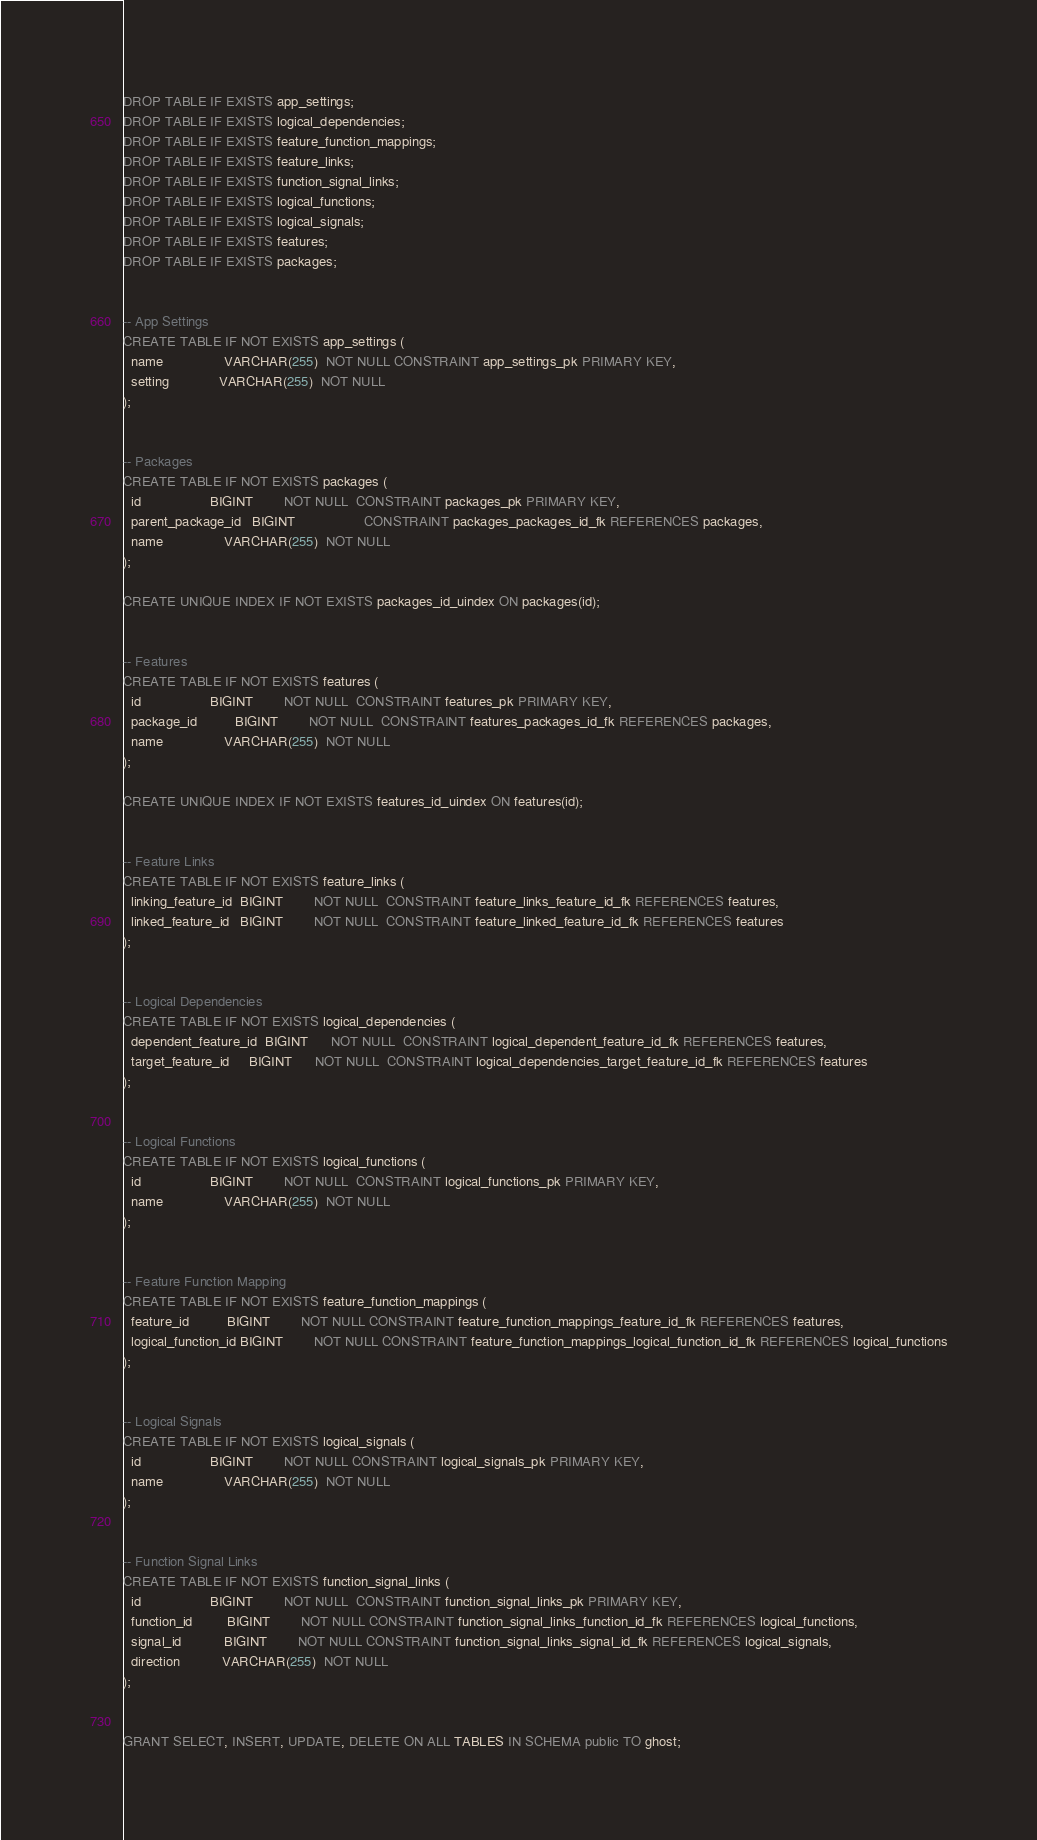<code> <loc_0><loc_0><loc_500><loc_500><_SQL_>DROP TABLE IF EXISTS app_settings;
DROP TABLE IF EXISTS logical_dependencies;
DROP TABLE IF EXISTS feature_function_mappings;
DROP TABLE IF EXISTS feature_links;
DROP TABLE IF EXISTS function_signal_links;
DROP TABLE IF EXISTS logical_functions;
DROP TABLE IF EXISTS logical_signals;
DROP TABLE IF EXISTS features;
DROP TABLE IF EXISTS packages;


-- App Settings
CREATE TABLE IF NOT EXISTS app_settings (
  name                VARCHAR(255)  NOT NULL CONSTRAINT app_settings_pk PRIMARY KEY,
  setting             VARCHAR(255)  NOT NULL
);


-- Packages
CREATE TABLE IF NOT EXISTS packages (
  id                  BIGINT        NOT NULL  CONSTRAINT packages_pk PRIMARY KEY,
  parent_package_id   BIGINT                  CONSTRAINT packages_packages_id_fk REFERENCES packages,
  name                VARCHAR(255)  NOT NULL
);

CREATE UNIQUE INDEX IF NOT EXISTS packages_id_uindex ON packages(id);


-- Features
CREATE TABLE IF NOT EXISTS features (
  id                  BIGINT        NOT NULL  CONSTRAINT features_pk PRIMARY KEY,
  package_id          BIGINT        NOT NULL  CONSTRAINT features_packages_id_fk REFERENCES packages,
  name                VARCHAR(255)  NOT NULL
);

CREATE UNIQUE INDEX IF NOT EXISTS features_id_uindex ON features(id);


-- Feature Links
CREATE TABLE IF NOT EXISTS feature_links (
  linking_feature_id  BIGINT        NOT NULL  CONSTRAINT feature_links_feature_id_fk REFERENCES features,
  linked_feature_id   BIGINT        NOT NULL  CONSTRAINT feature_linked_feature_id_fk REFERENCES features
);


-- Logical Dependencies
CREATE TABLE IF NOT EXISTS logical_dependencies (
  dependent_feature_id  BIGINT      NOT NULL  CONSTRAINT logical_dependent_feature_id_fk REFERENCES features,
  target_feature_id     BIGINT      NOT NULL  CONSTRAINT logical_dependencies_target_feature_id_fk REFERENCES features
);


-- Logical Functions
CREATE TABLE IF NOT EXISTS logical_functions (
  id                  BIGINT        NOT NULL  CONSTRAINT logical_functions_pk PRIMARY KEY,
  name                VARCHAR(255)  NOT NULL
);


-- Feature Function Mapping
CREATE TABLE IF NOT EXISTS feature_function_mappings (
  feature_id          BIGINT        NOT NULL CONSTRAINT feature_function_mappings_feature_id_fk REFERENCES features,
  logical_function_id BIGINT        NOT NULL CONSTRAINT feature_function_mappings_logical_function_id_fk REFERENCES logical_functions
);


-- Logical Signals
CREATE TABLE IF NOT EXISTS logical_signals (
  id                  BIGINT        NOT NULL CONSTRAINT logical_signals_pk PRIMARY KEY,
  name                VARCHAR(255)  NOT NULL
);


-- Function Signal Links
CREATE TABLE IF NOT EXISTS function_signal_links (
  id                  BIGINT        NOT NULL  CONSTRAINT function_signal_links_pk PRIMARY KEY,
  function_id         BIGINT        NOT NULL CONSTRAINT function_signal_links_function_id_fk REFERENCES logical_functions,
  signal_id           BIGINT        NOT NULL CONSTRAINT function_signal_links_signal_id_fk REFERENCES logical_signals,
  direction           VARCHAR(255)  NOT NULL
);


GRANT SELECT, INSERT, UPDATE, DELETE ON ALL TABLES IN SCHEMA public TO ghost;
</code> 